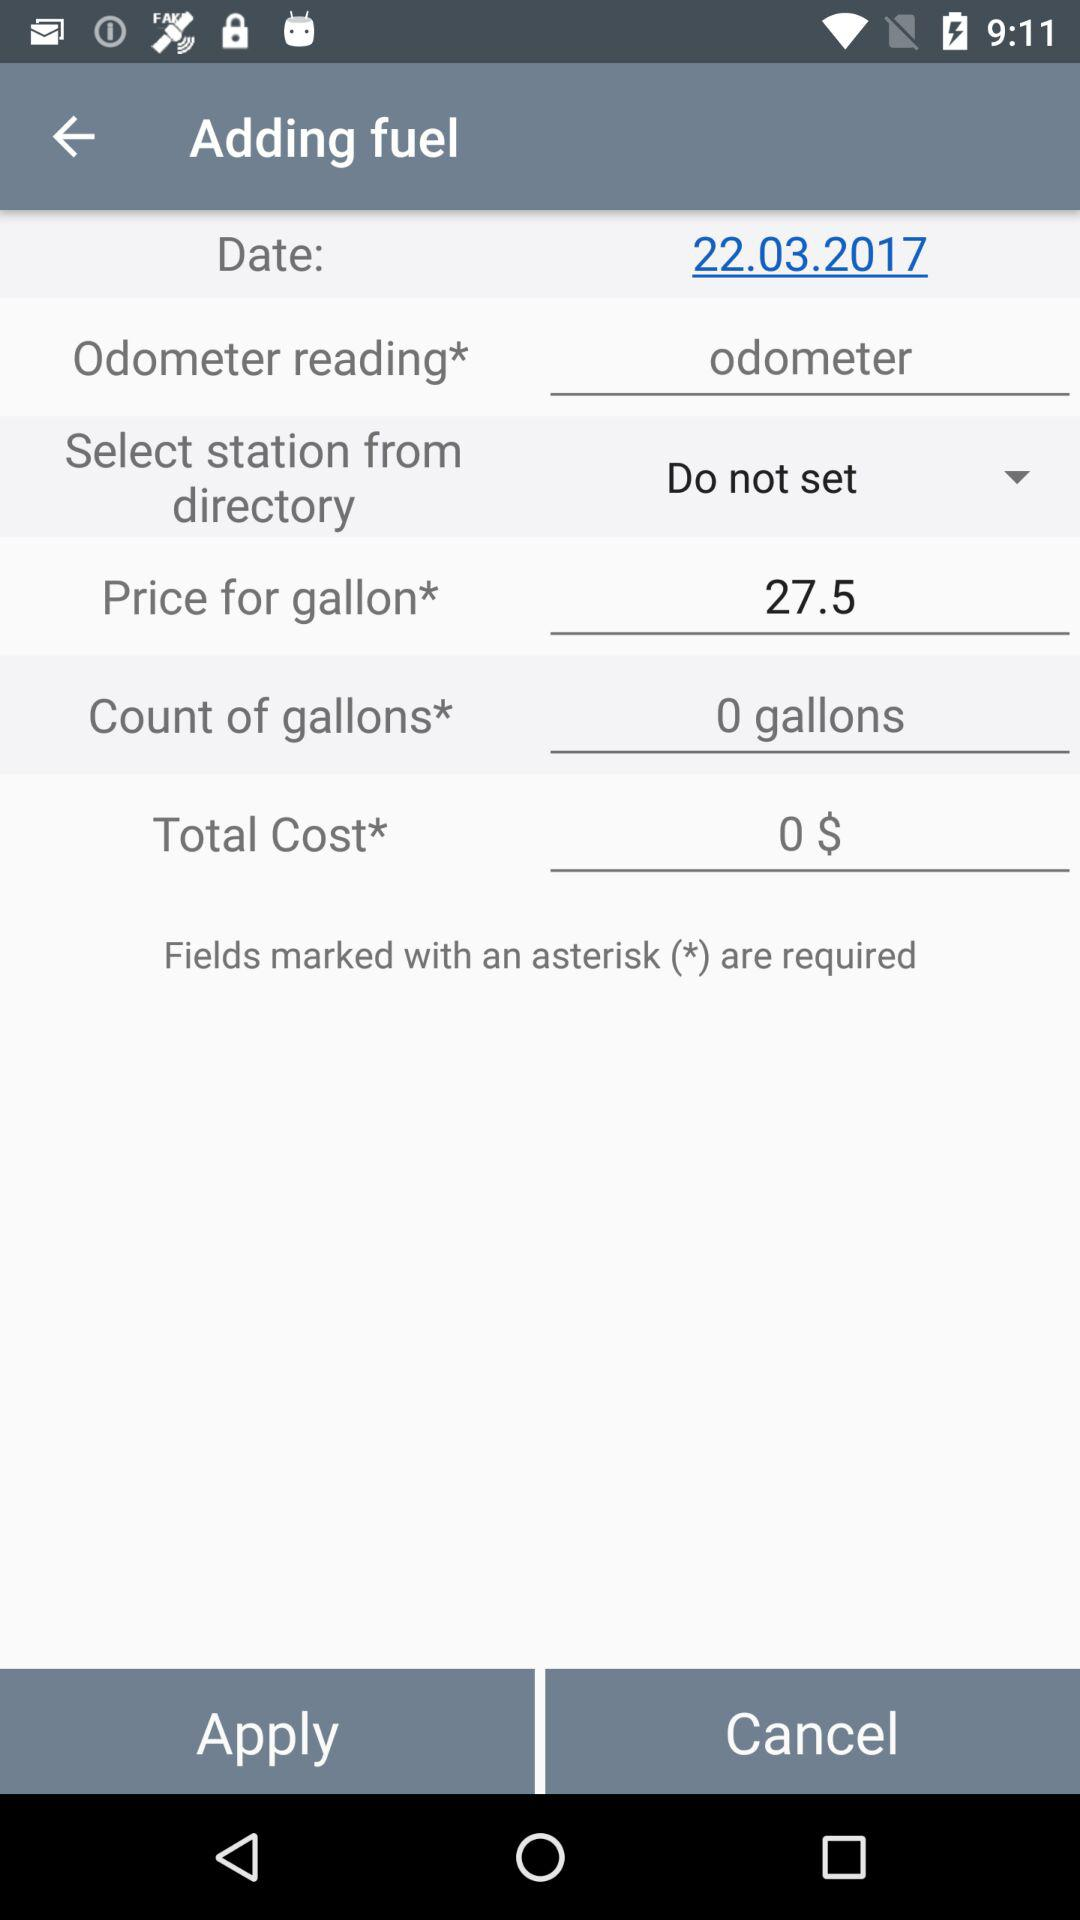On what date is the fuel being added? The fuel is being added on March 22, 2017. 